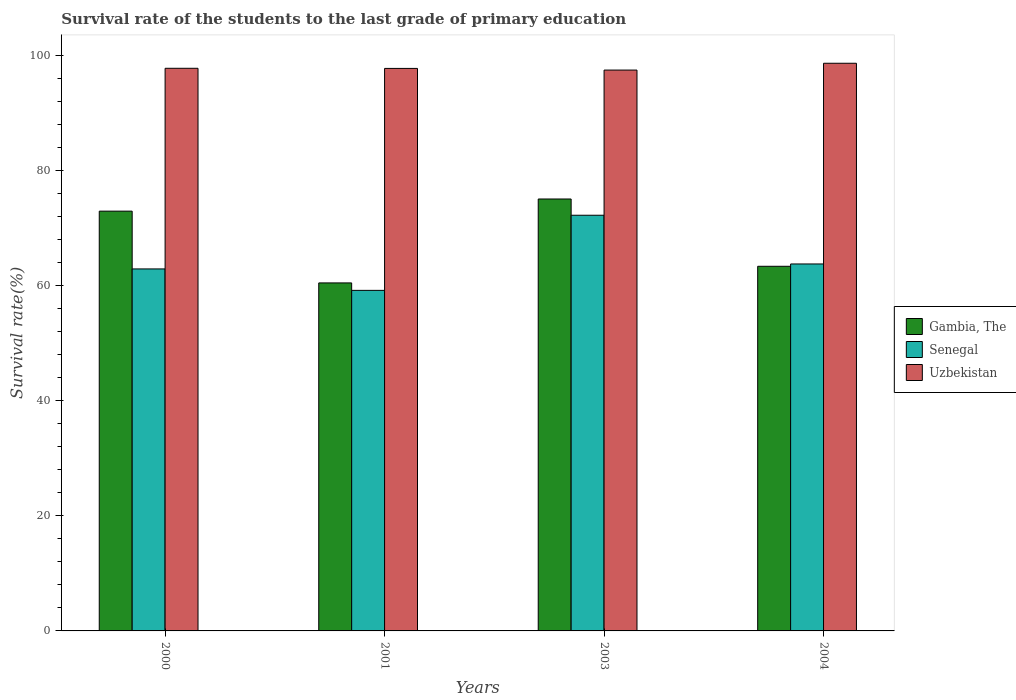How many groups of bars are there?
Your answer should be very brief. 4. Are the number of bars per tick equal to the number of legend labels?
Your answer should be very brief. Yes. Are the number of bars on each tick of the X-axis equal?
Provide a succinct answer. Yes. How many bars are there on the 3rd tick from the left?
Offer a very short reply. 3. How many bars are there on the 3rd tick from the right?
Your answer should be very brief. 3. What is the label of the 2nd group of bars from the left?
Keep it short and to the point. 2001. What is the survival rate of the students in Uzbekistan in 2004?
Your answer should be very brief. 98.62. Across all years, what is the maximum survival rate of the students in Uzbekistan?
Offer a very short reply. 98.62. Across all years, what is the minimum survival rate of the students in Gambia, The?
Your answer should be very brief. 60.46. In which year was the survival rate of the students in Senegal maximum?
Your answer should be compact. 2003. In which year was the survival rate of the students in Uzbekistan minimum?
Ensure brevity in your answer.  2003. What is the total survival rate of the students in Senegal in the graph?
Keep it short and to the point. 258.01. What is the difference between the survival rate of the students in Uzbekistan in 2001 and that in 2003?
Keep it short and to the point. 0.29. What is the difference between the survival rate of the students in Gambia, The in 2003 and the survival rate of the students in Senegal in 2004?
Your response must be concise. 11.29. What is the average survival rate of the students in Uzbekistan per year?
Your answer should be very brief. 97.88. In the year 2000, what is the difference between the survival rate of the students in Senegal and survival rate of the students in Uzbekistan?
Provide a short and direct response. -34.85. What is the ratio of the survival rate of the students in Uzbekistan in 2003 to that in 2004?
Your answer should be very brief. 0.99. Is the survival rate of the students in Uzbekistan in 2000 less than that in 2004?
Your answer should be very brief. Yes. Is the difference between the survival rate of the students in Senegal in 2000 and 2004 greater than the difference between the survival rate of the students in Uzbekistan in 2000 and 2004?
Offer a very short reply. Yes. What is the difference between the highest and the second highest survival rate of the students in Gambia, The?
Offer a terse response. 2.11. What is the difference between the highest and the lowest survival rate of the students in Uzbekistan?
Your response must be concise. 1.18. In how many years, is the survival rate of the students in Gambia, The greater than the average survival rate of the students in Gambia, The taken over all years?
Your answer should be very brief. 2. What does the 1st bar from the left in 2004 represents?
Offer a terse response. Gambia, The. What does the 1st bar from the right in 2003 represents?
Keep it short and to the point. Uzbekistan. What is the difference between two consecutive major ticks on the Y-axis?
Your answer should be compact. 20. Are the values on the major ticks of Y-axis written in scientific E-notation?
Provide a short and direct response. No. Where does the legend appear in the graph?
Make the answer very short. Center right. How many legend labels are there?
Your response must be concise. 3. How are the legend labels stacked?
Provide a short and direct response. Vertical. What is the title of the graph?
Your response must be concise. Survival rate of the students to the last grade of primary education. Does "Aruba" appear as one of the legend labels in the graph?
Your answer should be compact. No. What is the label or title of the X-axis?
Your response must be concise. Years. What is the label or title of the Y-axis?
Keep it short and to the point. Survival rate(%). What is the Survival rate(%) in Gambia, The in 2000?
Offer a terse response. 72.92. What is the Survival rate(%) of Senegal in 2000?
Keep it short and to the point. 62.89. What is the Survival rate(%) in Uzbekistan in 2000?
Provide a succinct answer. 97.74. What is the Survival rate(%) in Gambia, The in 2001?
Your answer should be very brief. 60.46. What is the Survival rate(%) in Senegal in 2001?
Ensure brevity in your answer.  59.16. What is the Survival rate(%) of Uzbekistan in 2001?
Provide a succinct answer. 97.72. What is the Survival rate(%) in Gambia, The in 2003?
Your answer should be compact. 75.04. What is the Survival rate(%) in Senegal in 2003?
Your answer should be very brief. 72.21. What is the Survival rate(%) of Uzbekistan in 2003?
Provide a short and direct response. 97.43. What is the Survival rate(%) in Gambia, The in 2004?
Offer a terse response. 63.34. What is the Survival rate(%) of Senegal in 2004?
Offer a very short reply. 63.75. What is the Survival rate(%) of Uzbekistan in 2004?
Give a very brief answer. 98.62. Across all years, what is the maximum Survival rate(%) in Gambia, The?
Give a very brief answer. 75.04. Across all years, what is the maximum Survival rate(%) of Senegal?
Your response must be concise. 72.21. Across all years, what is the maximum Survival rate(%) in Uzbekistan?
Offer a very short reply. 98.62. Across all years, what is the minimum Survival rate(%) in Gambia, The?
Offer a very short reply. 60.46. Across all years, what is the minimum Survival rate(%) of Senegal?
Provide a succinct answer. 59.16. Across all years, what is the minimum Survival rate(%) in Uzbekistan?
Provide a succinct answer. 97.43. What is the total Survival rate(%) of Gambia, The in the graph?
Offer a very short reply. 271.76. What is the total Survival rate(%) of Senegal in the graph?
Your answer should be very brief. 258.01. What is the total Survival rate(%) of Uzbekistan in the graph?
Ensure brevity in your answer.  391.51. What is the difference between the Survival rate(%) in Gambia, The in 2000 and that in 2001?
Keep it short and to the point. 12.47. What is the difference between the Survival rate(%) of Senegal in 2000 and that in 2001?
Provide a short and direct response. 3.73. What is the difference between the Survival rate(%) in Uzbekistan in 2000 and that in 2001?
Ensure brevity in your answer.  0.02. What is the difference between the Survival rate(%) in Gambia, The in 2000 and that in 2003?
Give a very brief answer. -2.11. What is the difference between the Survival rate(%) in Senegal in 2000 and that in 2003?
Offer a very short reply. -9.32. What is the difference between the Survival rate(%) of Uzbekistan in 2000 and that in 2003?
Your response must be concise. 0.31. What is the difference between the Survival rate(%) in Gambia, The in 2000 and that in 2004?
Your answer should be very brief. 9.58. What is the difference between the Survival rate(%) in Senegal in 2000 and that in 2004?
Your answer should be very brief. -0.86. What is the difference between the Survival rate(%) of Uzbekistan in 2000 and that in 2004?
Make the answer very short. -0.88. What is the difference between the Survival rate(%) of Gambia, The in 2001 and that in 2003?
Give a very brief answer. -14.58. What is the difference between the Survival rate(%) of Senegal in 2001 and that in 2003?
Provide a short and direct response. -13.05. What is the difference between the Survival rate(%) of Uzbekistan in 2001 and that in 2003?
Your response must be concise. 0.29. What is the difference between the Survival rate(%) of Gambia, The in 2001 and that in 2004?
Make the answer very short. -2.89. What is the difference between the Survival rate(%) of Senegal in 2001 and that in 2004?
Make the answer very short. -4.59. What is the difference between the Survival rate(%) in Uzbekistan in 2001 and that in 2004?
Offer a very short reply. -0.9. What is the difference between the Survival rate(%) of Gambia, The in 2003 and that in 2004?
Your answer should be compact. 11.69. What is the difference between the Survival rate(%) in Senegal in 2003 and that in 2004?
Provide a short and direct response. 8.46. What is the difference between the Survival rate(%) of Uzbekistan in 2003 and that in 2004?
Your answer should be very brief. -1.18. What is the difference between the Survival rate(%) in Gambia, The in 2000 and the Survival rate(%) in Senegal in 2001?
Your response must be concise. 13.76. What is the difference between the Survival rate(%) in Gambia, The in 2000 and the Survival rate(%) in Uzbekistan in 2001?
Provide a short and direct response. -24.8. What is the difference between the Survival rate(%) of Senegal in 2000 and the Survival rate(%) of Uzbekistan in 2001?
Make the answer very short. -34.83. What is the difference between the Survival rate(%) of Gambia, The in 2000 and the Survival rate(%) of Senegal in 2003?
Your response must be concise. 0.71. What is the difference between the Survival rate(%) in Gambia, The in 2000 and the Survival rate(%) in Uzbekistan in 2003?
Offer a very short reply. -24.51. What is the difference between the Survival rate(%) of Senegal in 2000 and the Survival rate(%) of Uzbekistan in 2003?
Offer a very short reply. -34.54. What is the difference between the Survival rate(%) in Gambia, The in 2000 and the Survival rate(%) in Senegal in 2004?
Provide a succinct answer. 9.18. What is the difference between the Survival rate(%) in Gambia, The in 2000 and the Survival rate(%) in Uzbekistan in 2004?
Offer a very short reply. -25.69. What is the difference between the Survival rate(%) in Senegal in 2000 and the Survival rate(%) in Uzbekistan in 2004?
Your answer should be very brief. -35.73. What is the difference between the Survival rate(%) of Gambia, The in 2001 and the Survival rate(%) of Senegal in 2003?
Ensure brevity in your answer.  -11.76. What is the difference between the Survival rate(%) of Gambia, The in 2001 and the Survival rate(%) of Uzbekistan in 2003?
Your answer should be compact. -36.98. What is the difference between the Survival rate(%) in Senegal in 2001 and the Survival rate(%) in Uzbekistan in 2003?
Ensure brevity in your answer.  -38.27. What is the difference between the Survival rate(%) in Gambia, The in 2001 and the Survival rate(%) in Senegal in 2004?
Provide a short and direct response. -3.29. What is the difference between the Survival rate(%) of Gambia, The in 2001 and the Survival rate(%) of Uzbekistan in 2004?
Your answer should be very brief. -38.16. What is the difference between the Survival rate(%) in Senegal in 2001 and the Survival rate(%) in Uzbekistan in 2004?
Your response must be concise. -39.45. What is the difference between the Survival rate(%) in Gambia, The in 2003 and the Survival rate(%) in Senegal in 2004?
Make the answer very short. 11.29. What is the difference between the Survival rate(%) of Gambia, The in 2003 and the Survival rate(%) of Uzbekistan in 2004?
Provide a succinct answer. -23.58. What is the difference between the Survival rate(%) of Senegal in 2003 and the Survival rate(%) of Uzbekistan in 2004?
Your response must be concise. -26.4. What is the average Survival rate(%) of Gambia, The per year?
Provide a succinct answer. 67.94. What is the average Survival rate(%) of Senegal per year?
Make the answer very short. 64.5. What is the average Survival rate(%) of Uzbekistan per year?
Ensure brevity in your answer.  97.88. In the year 2000, what is the difference between the Survival rate(%) in Gambia, The and Survival rate(%) in Senegal?
Offer a terse response. 10.04. In the year 2000, what is the difference between the Survival rate(%) of Gambia, The and Survival rate(%) of Uzbekistan?
Offer a very short reply. -24.82. In the year 2000, what is the difference between the Survival rate(%) in Senegal and Survival rate(%) in Uzbekistan?
Give a very brief answer. -34.85. In the year 2001, what is the difference between the Survival rate(%) of Gambia, The and Survival rate(%) of Senegal?
Keep it short and to the point. 1.29. In the year 2001, what is the difference between the Survival rate(%) in Gambia, The and Survival rate(%) in Uzbekistan?
Provide a short and direct response. -37.26. In the year 2001, what is the difference between the Survival rate(%) of Senegal and Survival rate(%) of Uzbekistan?
Make the answer very short. -38.56. In the year 2003, what is the difference between the Survival rate(%) in Gambia, The and Survival rate(%) in Senegal?
Keep it short and to the point. 2.82. In the year 2003, what is the difference between the Survival rate(%) in Gambia, The and Survival rate(%) in Uzbekistan?
Offer a very short reply. -22.4. In the year 2003, what is the difference between the Survival rate(%) in Senegal and Survival rate(%) in Uzbekistan?
Your response must be concise. -25.22. In the year 2004, what is the difference between the Survival rate(%) of Gambia, The and Survival rate(%) of Senegal?
Ensure brevity in your answer.  -0.4. In the year 2004, what is the difference between the Survival rate(%) of Gambia, The and Survival rate(%) of Uzbekistan?
Make the answer very short. -35.27. In the year 2004, what is the difference between the Survival rate(%) in Senegal and Survival rate(%) in Uzbekistan?
Offer a terse response. -34.87. What is the ratio of the Survival rate(%) in Gambia, The in 2000 to that in 2001?
Give a very brief answer. 1.21. What is the ratio of the Survival rate(%) in Senegal in 2000 to that in 2001?
Give a very brief answer. 1.06. What is the ratio of the Survival rate(%) in Uzbekistan in 2000 to that in 2001?
Your answer should be very brief. 1. What is the ratio of the Survival rate(%) in Gambia, The in 2000 to that in 2003?
Your answer should be very brief. 0.97. What is the ratio of the Survival rate(%) in Senegal in 2000 to that in 2003?
Provide a succinct answer. 0.87. What is the ratio of the Survival rate(%) in Uzbekistan in 2000 to that in 2003?
Your answer should be very brief. 1. What is the ratio of the Survival rate(%) in Gambia, The in 2000 to that in 2004?
Your response must be concise. 1.15. What is the ratio of the Survival rate(%) of Senegal in 2000 to that in 2004?
Offer a very short reply. 0.99. What is the ratio of the Survival rate(%) of Uzbekistan in 2000 to that in 2004?
Provide a short and direct response. 0.99. What is the ratio of the Survival rate(%) in Gambia, The in 2001 to that in 2003?
Provide a short and direct response. 0.81. What is the ratio of the Survival rate(%) in Senegal in 2001 to that in 2003?
Ensure brevity in your answer.  0.82. What is the ratio of the Survival rate(%) in Uzbekistan in 2001 to that in 2003?
Offer a terse response. 1. What is the ratio of the Survival rate(%) of Gambia, The in 2001 to that in 2004?
Your answer should be very brief. 0.95. What is the ratio of the Survival rate(%) in Senegal in 2001 to that in 2004?
Keep it short and to the point. 0.93. What is the ratio of the Survival rate(%) in Uzbekistan in 2001 to that in 2004?
Keep it short and to the point. 0.99. What is the ratio of the Survival rate(%) in Gambia, The in 2003 to that in 2004?
Provide a short and direct response. 1.18. What is the ratio of the Survival rate(%) in Senegal in 2003 to that in 2004?
Your response must be concise. 1.13. What is the difference between the highest and the second highest Survival rate(%) of Gambia, The?
Keep it short and to the point. 2.11. What is the difference between the highest and the second highest Survival rate(%) in Senegal?
Your answer should be compact. 8.46. What is the difference between the highest and the second highest Survival rate(%) in Uzbekistan?
Offer a terse response. 0.88. What is the difference between the highest and the lowest Survival rate(%) in Gambia, The?
Give a very brief answer. 14.58. What is the difference between the highest and the lowest Survival rate(%) of Senegal?
Make the answer very short. 13.05. What is the difference between the highest and the lowest Survival rate(%) in Uzbekistan?
Your answer should be compact. 1.18. 